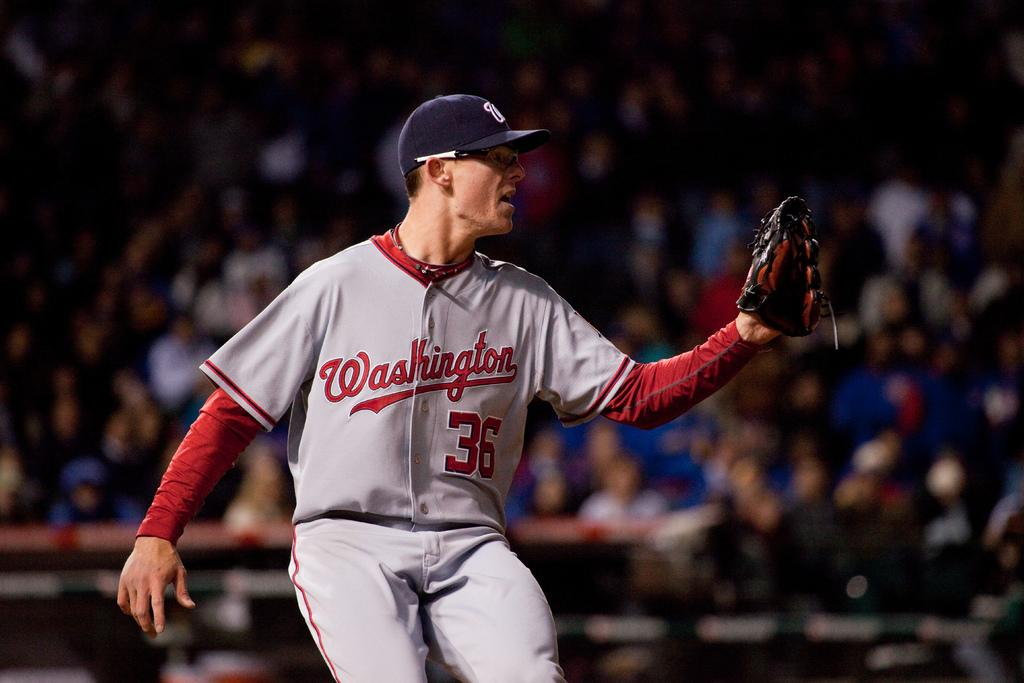Provide a one-sentence caption for the provided image. Washington Nationals player number 36 has a glove on his left hand. 